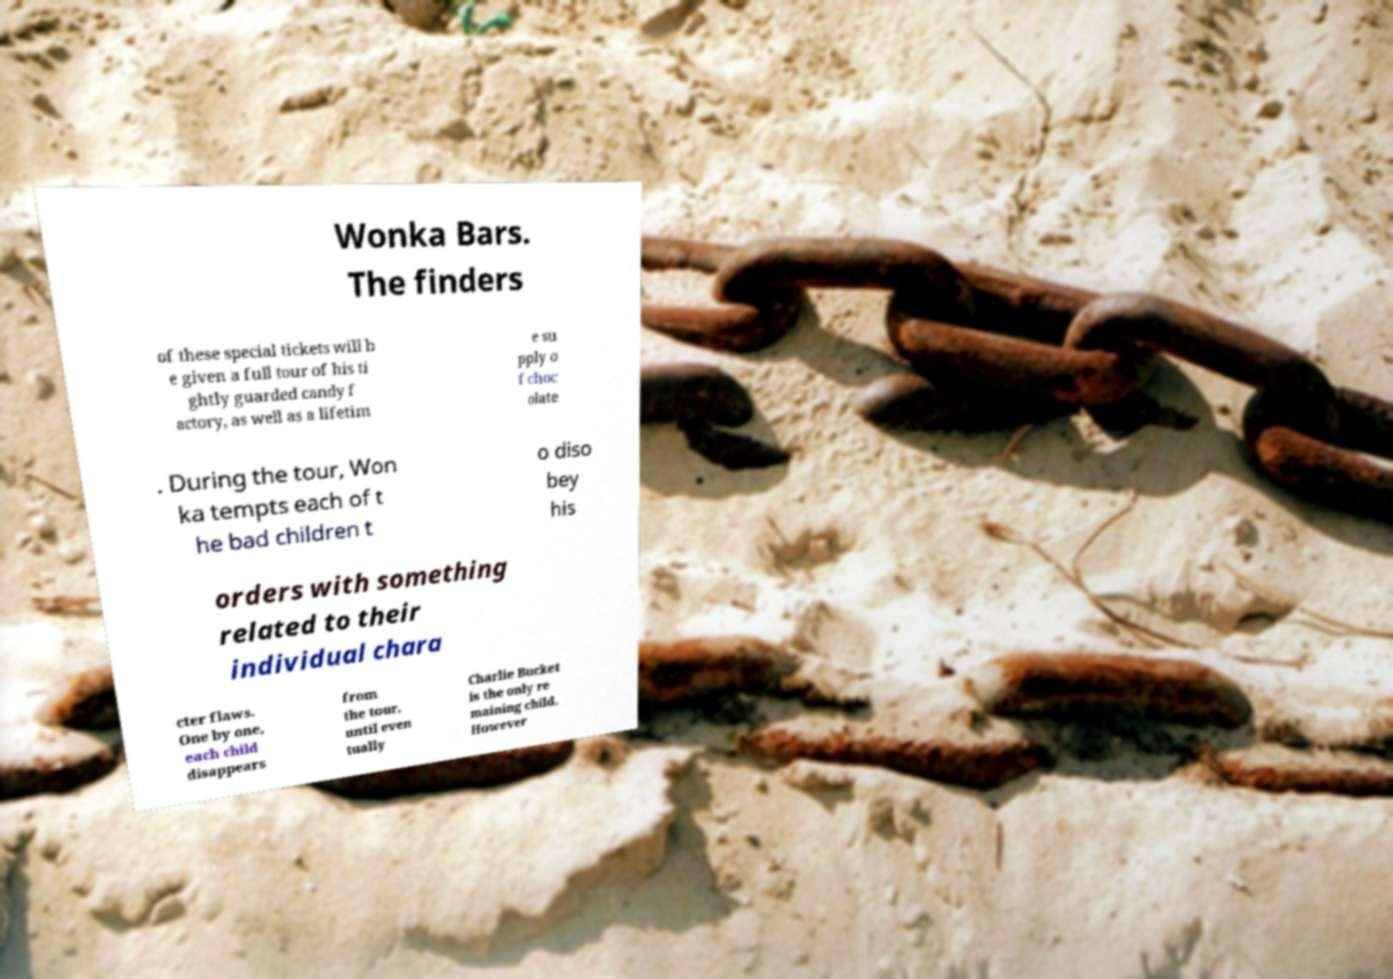Could you assist in decoding the text presented in this image and type it out clearly? Wonka Bars. The finders of these special tickets will b e given a full tour of his ti ghtly guarded candy f actory, as well as a lifetim e su pply o f choc olate . During the tour, Won ka tempts each of t he bad children t o diso bey his orders with something related to their individual chara cter flaws. One by one, each child disappears from the tour, until even tually Charlie Bucket is the only re maining child. However 